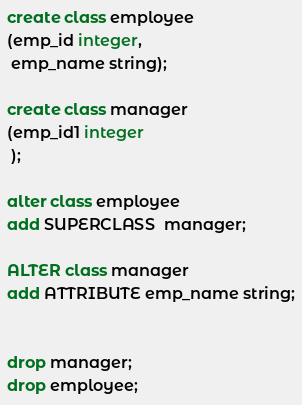<code> <loc_0><loc_0><loc_500><loc_500><_SQL_>create class employee
(emp_id integer,
 emp_name string);

create class manager
(emp_id1 integer
 );

alter class employee
add SUPERCLASS  manager;

ALTER class manager
add ATTRIBUTE emp_name string;


drop manager;
drop employee;
</code> 